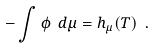<formula> <loc_0><loc_0><loc_500><loc_500>- \int \phi \ d \mu = h _ { \mu } ( T ) \ .</formula> 